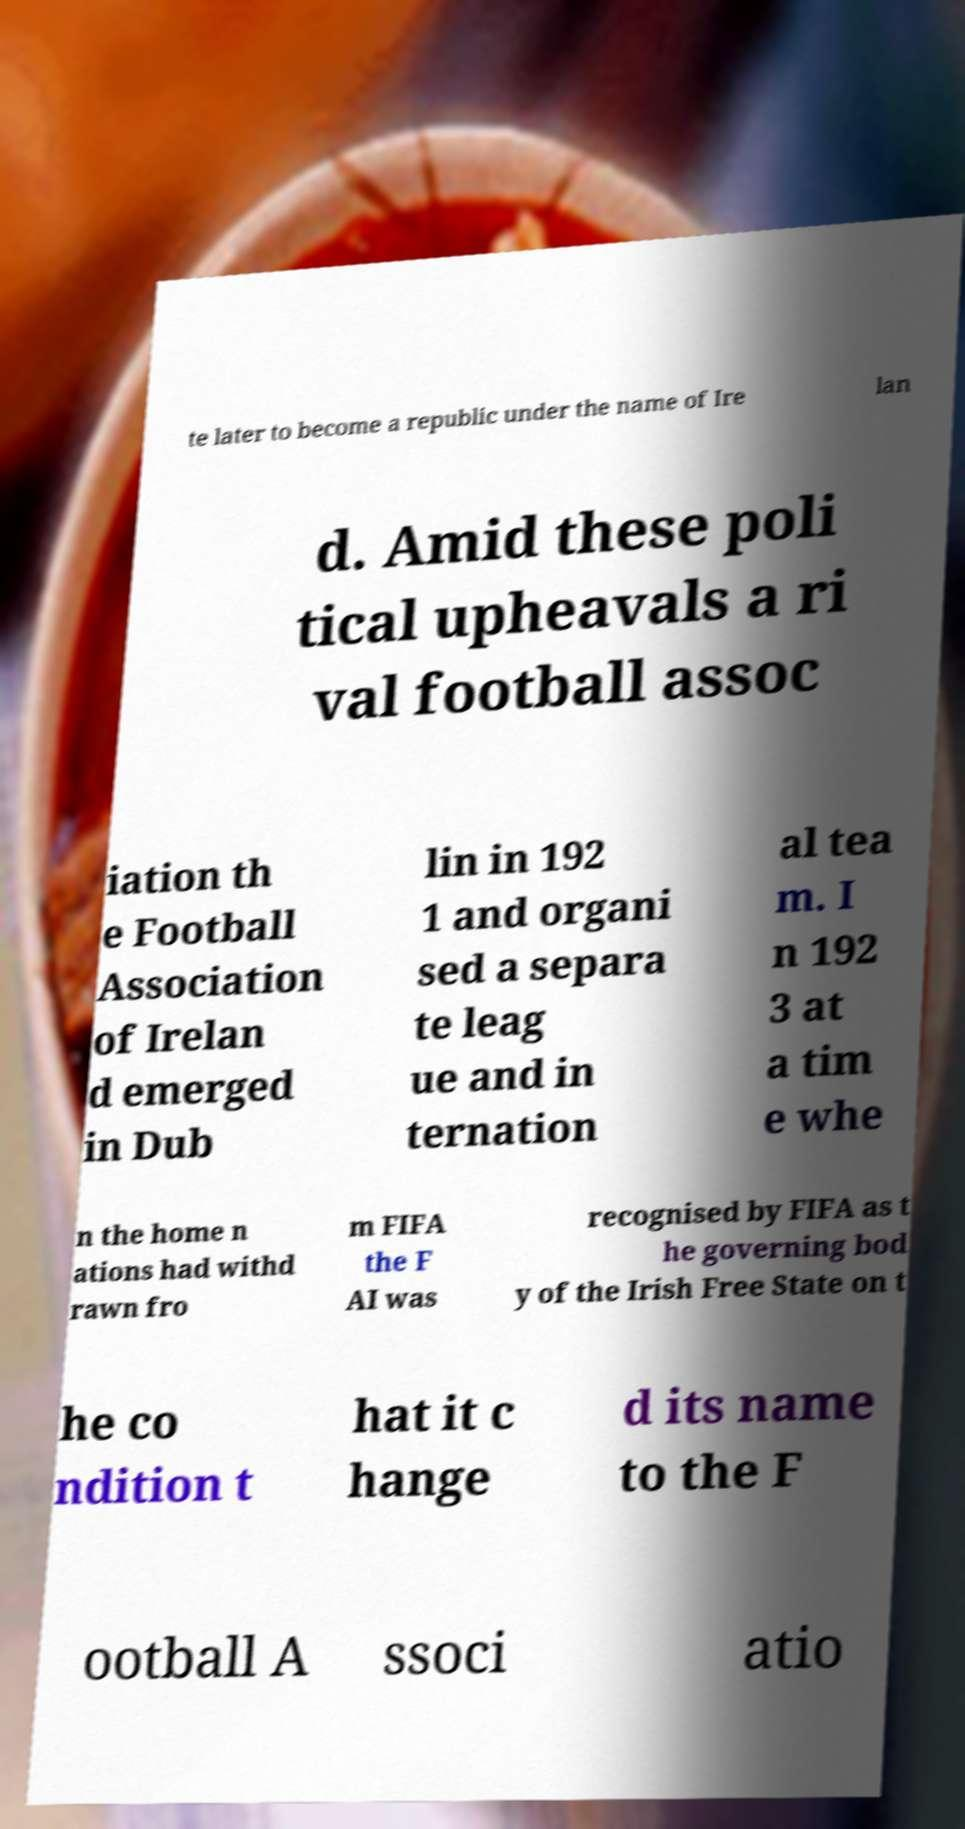I need the written content from this picture converted into text. Can you do that? te later to become a republic under the name of Ire lan d. Amid these poli tical upheavals a ri val football assoc iation th e Football Association of Irelan d emerged in Dub lin in 192 1 and organi sed a separa te leag ue and in ternation al tea m. I n 192 3 at a tim e whe n the home n ations had withd rawn fro m FIFA the F AI was recognised by FIFA as t he governing bod y of the Irish Free State on t he co ndition t hat it c hange d its name to the F ootball A ssoci atio 